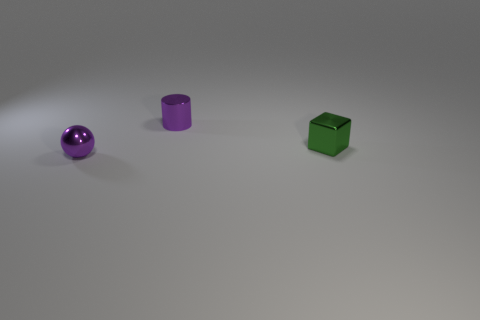Add 3 purple spheres. How many objects exist? 6 Subtract 0 green spheres. How many objects are left? 3 Subtract all spheres. How many objects are left? 2 Subtract all tiny brown matte spheres. Subtract all purple metal things. How many objects are left? 1 Add 1 shiny cylinders. How many shiny cylinders are left? 2 Add 2 big gray metallic spheres. How many big gray metallic spheres exist? 2 